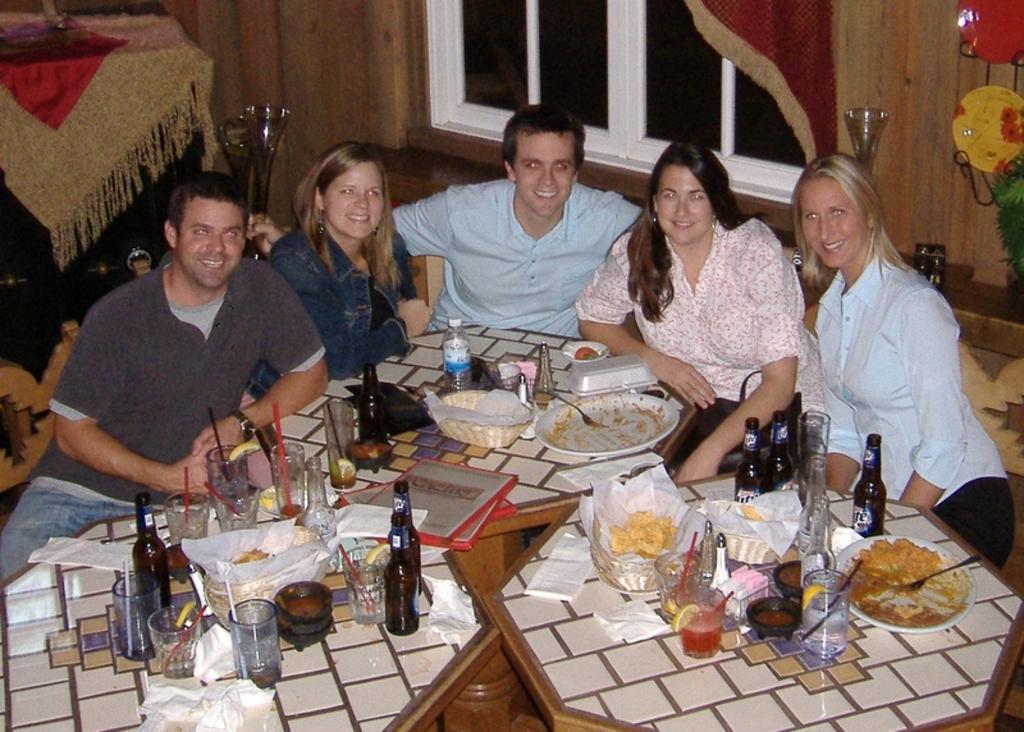How would you summarize this image in a sentence or two? In this image there are a few people sitting in front of the table, on the table there are bottles, glasses, bowls and some other food items are arranged. In the background there is a wall with a window. On the left side of the image there is an object. On the right side of the image there is a plant with decoration. 